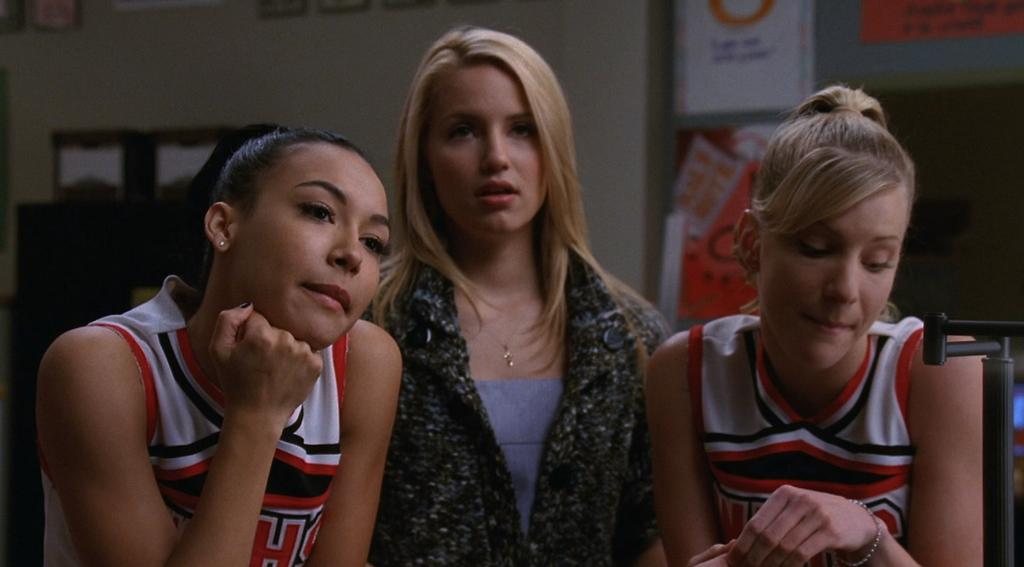Provide a one-sentence caption for the provided image. A cheerleader with the letter H on her shirt is with her friends. 